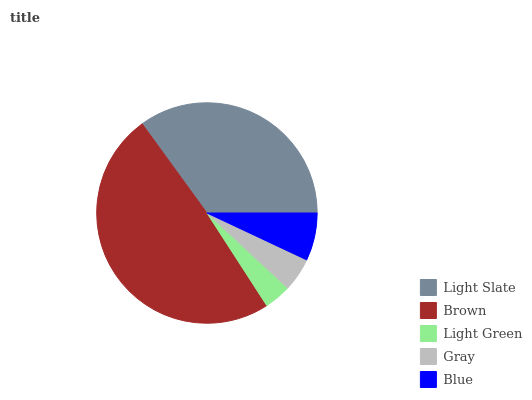Is Light Green the minimum?
Answer yes or no. Yes. Is Brown the maximum?
Answer yes or no. Yes. Is Brown the minimum?
Answer yes or no. No. Is Light Green the maximum?
Answer yes or no. No. Is Brown greater than Light Green?
Answer yes or no. Yes. Is Light Green less than Brown?
Answer yes or no. Yes. Is Light Green greater than Brown?
Answer yes or no. No. Is Brown less than Light Green?
Answer yes or no. No. Is Blue the high median?
Answer yes or no. Yes. Is Blue the low median?
Answer yes or no. Yes. Is Brown the high median?
Answer yes or no. No. Is Light Green the low median?
Answer yes or no. No. 